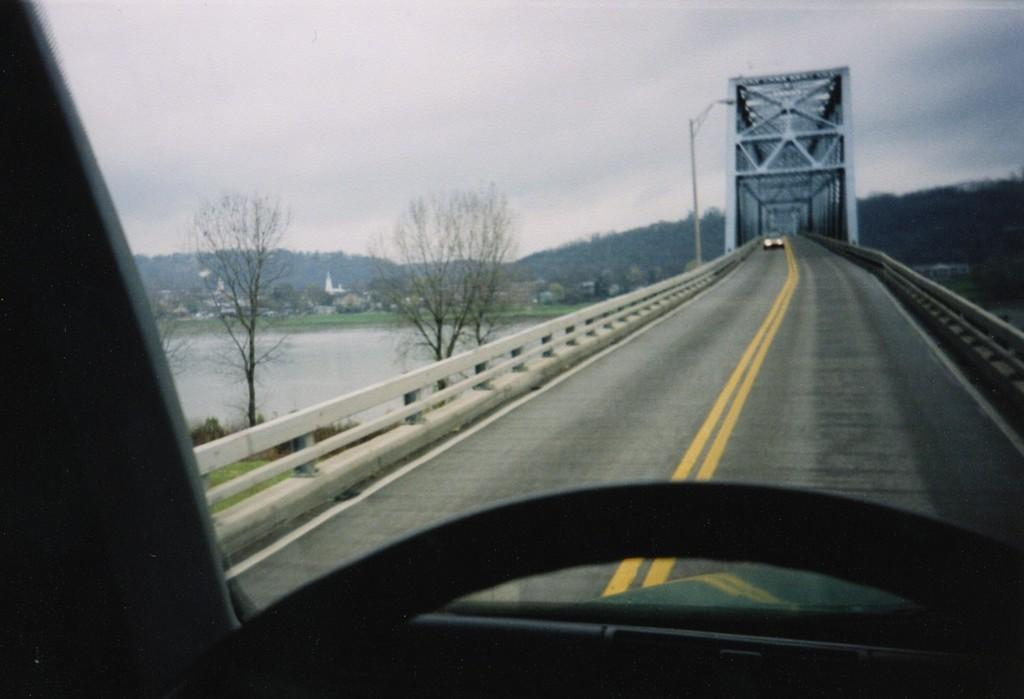What structure can be seen in the image? There is a bridge in the image. What is on the bridge? Vehicles are present on the bridge. What type of vegetation is on the left side of the image? There are trees on the left side of the image. What natural element is visible in the image? There is water visible in the image. What can be seen in the background of the image? There are hills, a pole, and the sky visible in the background of the image. What type of cord is being used to connect the planes in the image? There are no planes present in the image, so there is no cord connecting them. 